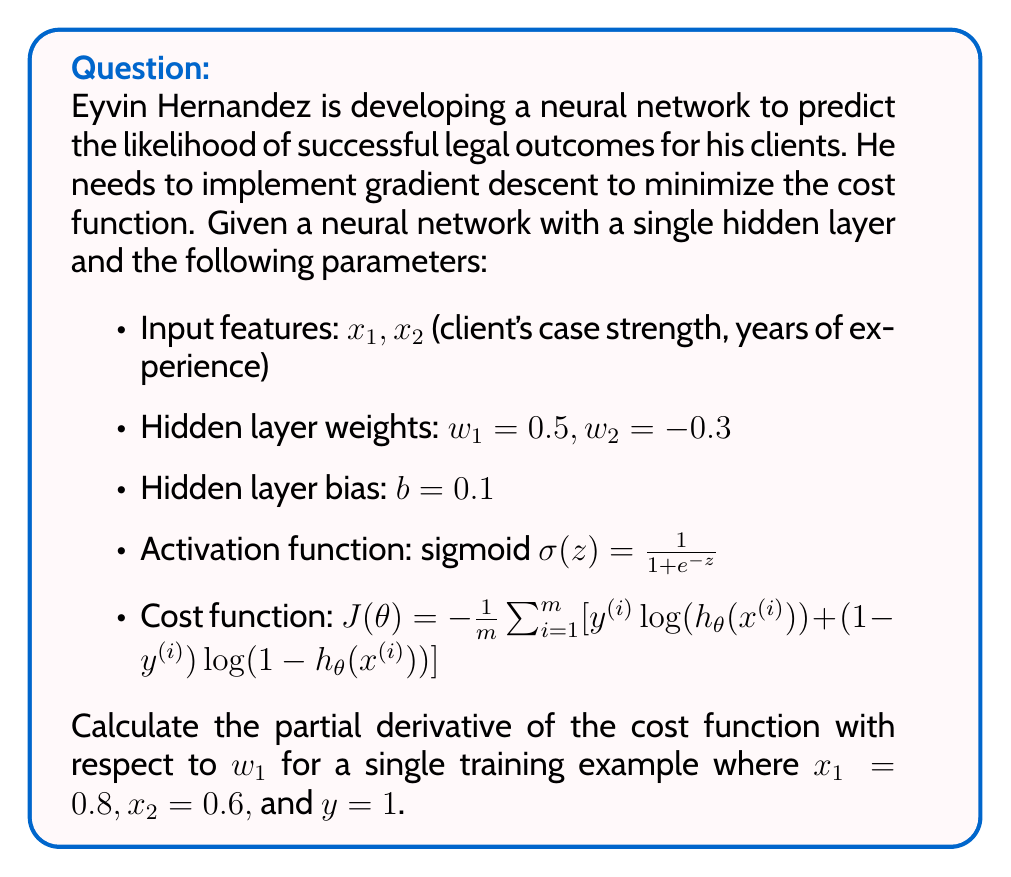Can you answer this question? To calculate the partial derivative of the cost function with respect to $w_1$, we'll use the chain rule and follow these steps:

1) First, let's calculate the output of the hidden layer:
   $$z = w_1x_1 + w_2x_2 + b = 0.5(0.8) + (-0.3)(0.6) + 0.1 = 0.32$$

2) Apply the sigmoid activation function:
   $$a = \sigma(z) = \frac{1}{1+e^{-0.32}} \approx 0.5793$$

3) For a single training example, the cost function simplifies to:
   $$J(\theta) = -[y\log(a) + (1-y)\log(1-a)]$$

4) The partial derivative of $J$ with respect to $a$ is:
   $$\frac{\partial J}{\partial a} = -\frac{y}{a} + \frac{1-y}{1-a} = -\frac{1}{0.5793} + 0 \approx -1.7262$$

5) The derivative of the sigmoid function is:
   $$\sigma'(z) = \sigma(z)(1-\sigma(z)) = 0.5793(1-0.5793) \approx 0.2437$$

6) The partial derivative of $z$ with respect to $w_1$ is simply $x_1 = 0.8$

7) Applying the chain rule:
   $$\frac{\partial J}{\partial w_1} = \frac{\partial J}{\partial a} \cdot \frac{\partial a}{\partial z} \cdot \frac{\partial z}{\partial w_1}$$
   $$= (-1.7262) \cdot (0.2437) \cdot (0.8) \approx -0.3366$$

Therefore, the partial derivative of the cost function with respect to $w_1$ for this single training example is approximately -0.3366.
Answer: $$\frac{\partial J}{\partial w_1} \approx -0.3366$$ 